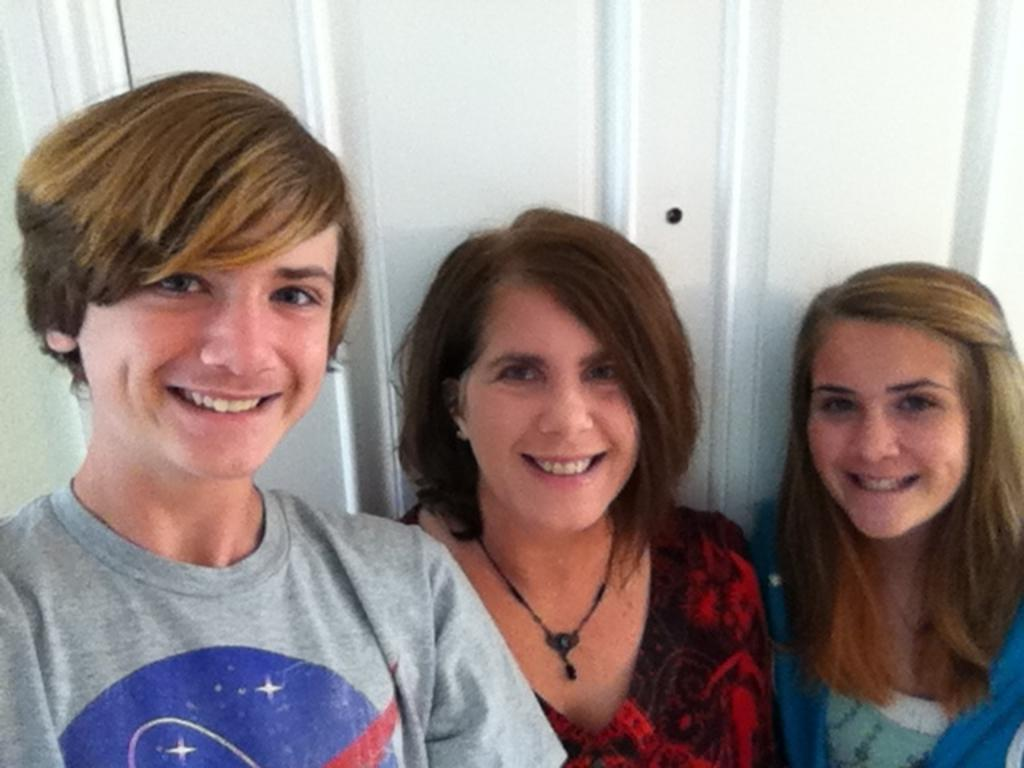How many people are in the image? There are three persons in the image. What expressions do the people have? The persons are smiling in the image. What can be seen in the background of the image? There is a white-colored wall in the background of the image. What type of pear is hanging from the scarf in the image? There is no pear or scarf present in the image. What scientific discovery is being celebrated in the image? There is no indication of a scientific discovery being celebrated in the image. 